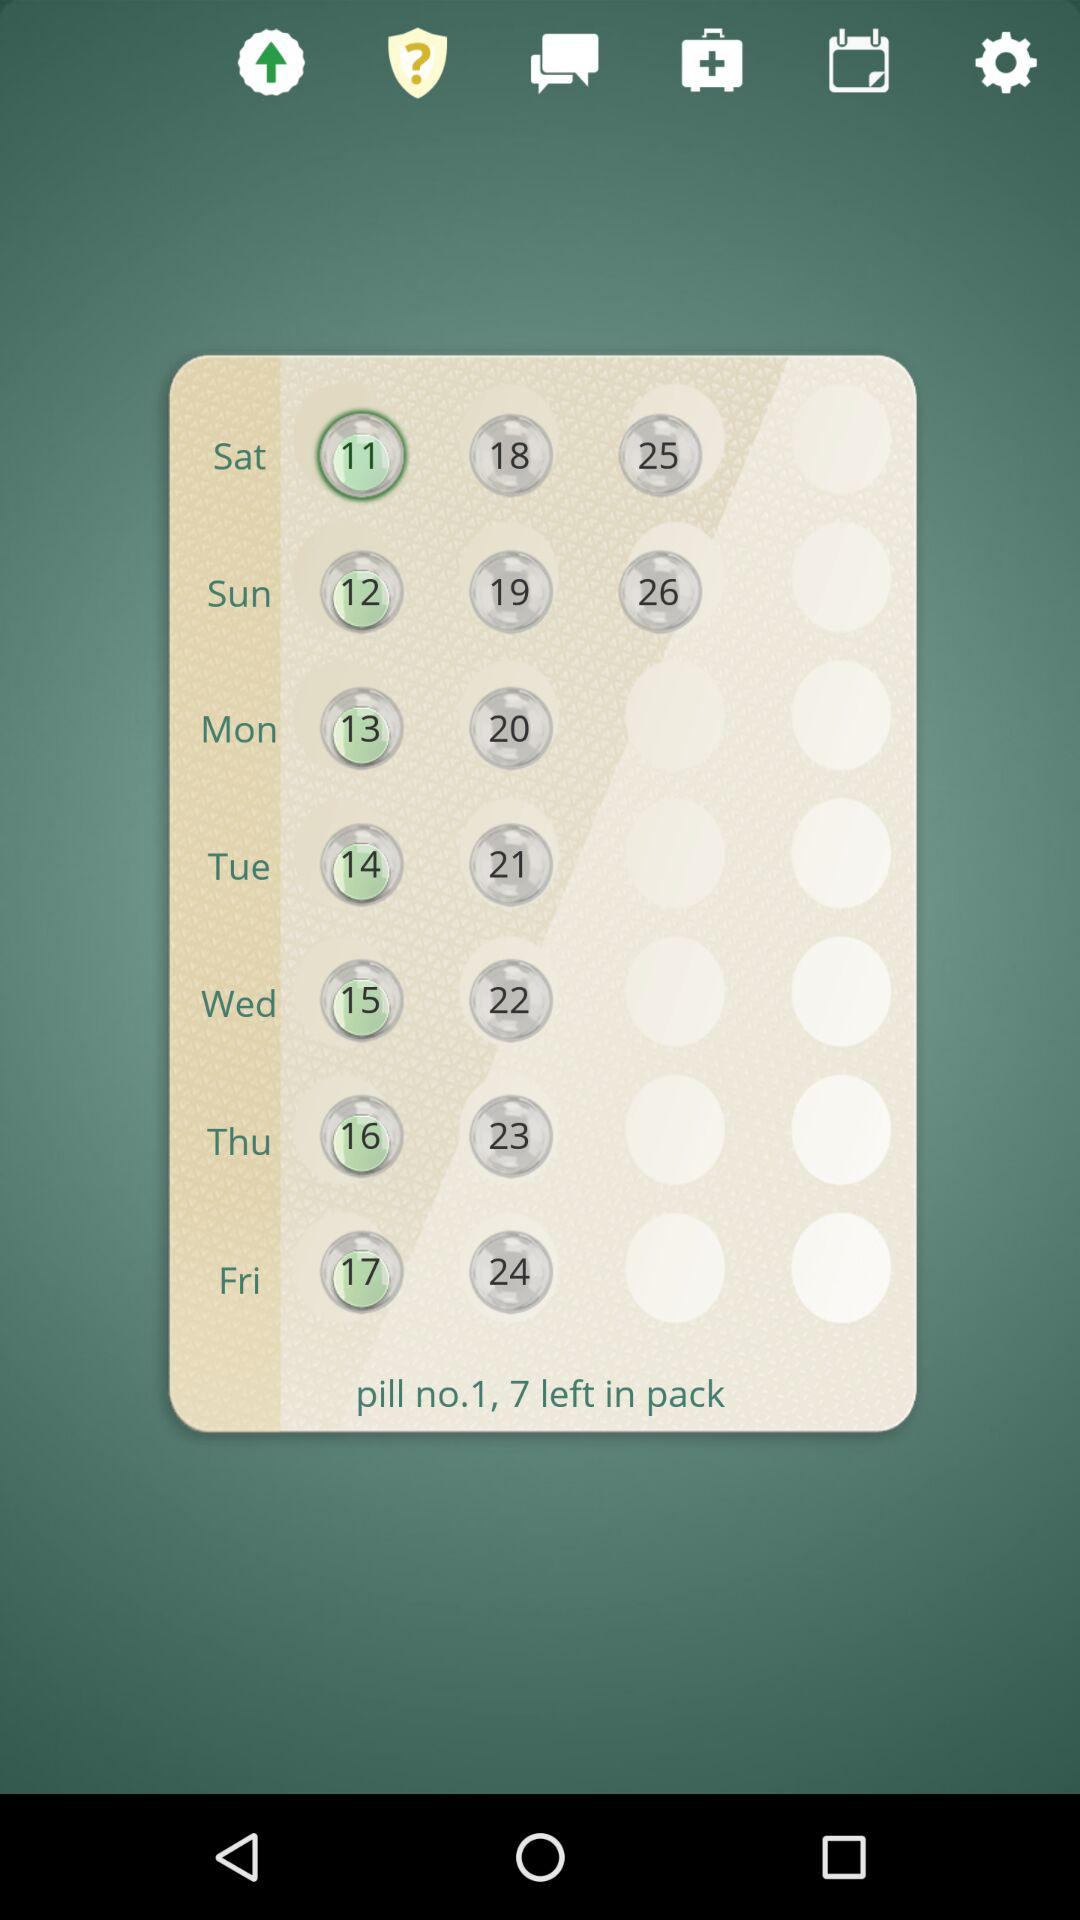How many pills are left in the pack?
Answer the question using a single word or phrase. 7 